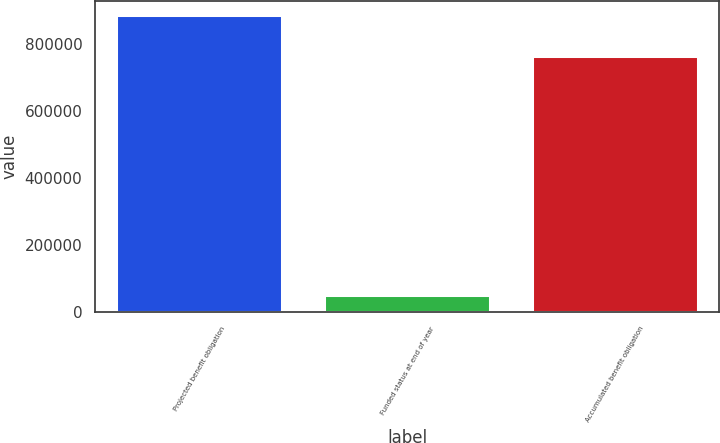Convert chart. <chart><loc_0><loc_0><loc_500><loc_500><bar_chart><fcel>Projected benefit obligation<fcel>Funded status at end of year<fcel>Accumulated benefit obligation<nl><fcel>884659<fcel>51973<fcel>764654<nl></chart> 